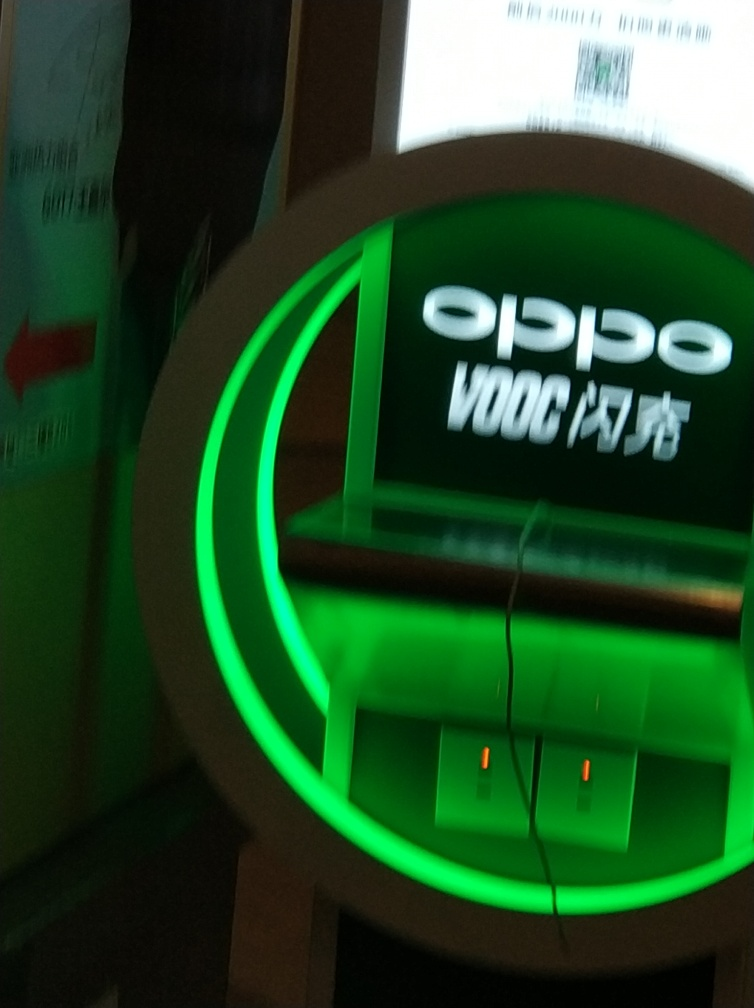What is the overall quality of the image?
A. poor
B. excellent
C. good
Answer with the option's letter from the given choices directly. The overall quality of the image could be perceived as poor (Option A). This judgment is based on the visible blurring and lack of sharpness, indicating motion blur or a low shutter speed was used when taking the picture, which impacts the image's clarity and detail. 